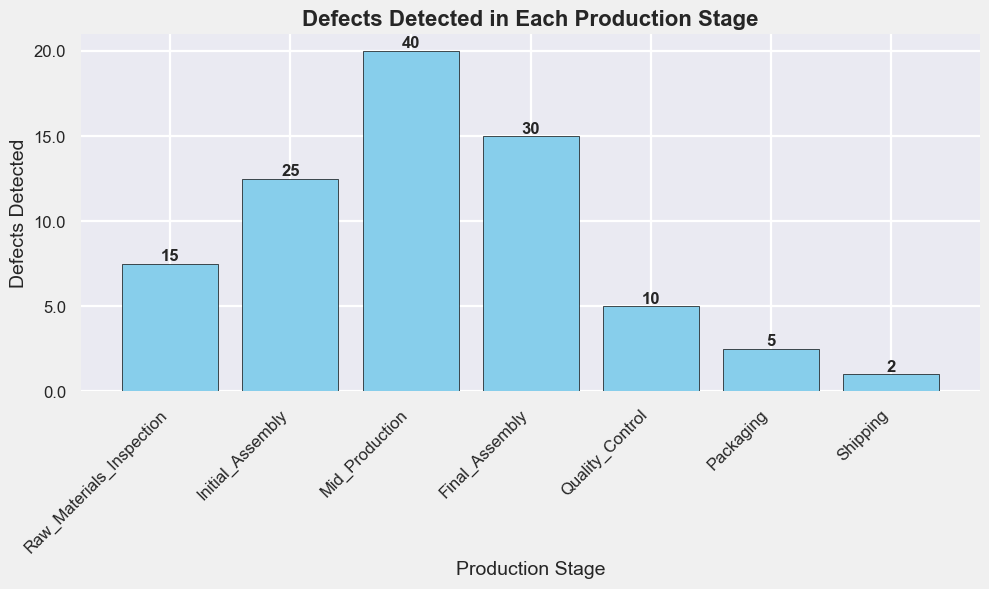Which production stage has the highest number of defects? By looking at the height of each bar, we can see that the 'Mid_Production' stage has the tallest bar. This means it has the highest number of defects.
Answer: Mid_Production Which production stage has the lowest number of defects? By observing the height of each bar and comparing them, we find that the 'Shipping' stage has the shortest bar, indicating the lowest number of defects.
Answer: Shipping How many more defects were detected in the 'Final_Assembly' stage compared to 'Quality_Control'? The number of defects in 'Final_Assembly' is 30 and in 'Quality_Control' is 10. Subtracting these gives us: 30 - 10 = 20.
Answer: 20 What is the total number of defects detected in all production stages? Summing up all the defects detected in each stage: 15 + 25 + 40 + 30 + 10 + 5 + 2 = 127.
Answer: 127 What is the average number of defects detected across all production stages? We sum up the defects detected in all stages, which is 127, and then divide by the number of stages, which is 7: 127 / 7 ≈ 18.14.
Answer: 18.14 How many defects were detected in stages before 'Final_Assembly'? Adding the defects detected from 'Raw_Materials_Inspection' to 'Mid_Production': 15 + 25 + 40 = 80.
Answer: 80 Which production stages have fewer than 10 defects detected? Comparing the heights of the bars, 'Packaging' and 'Shipping' stages have fewer than 10 defects detected, with defects count 5 and 2, respectively.
Answer: Packaging, Shipping Are defects detected in 'Mid_Production' stage more than the sum of 'Packaging' and 'Shipping' stages? The defects in 'Mid_Production' are 40. The sum of defects in 'Packaging' and 'Shipping' is 5 + 2 = 7. Since 40 is greater than 7, the answer is yes.
Answer: Yes What is the difference in defects between the 'Initial_Assembly' and 'Final_Assembly' stages? The number of defects in 'Initial_Assembly' is 25, and in 'Final_Assembly' is 30. Subtracting these gives us: 30 - 25 = 5.
Answer: 5 Which stage(s) detect(s) exactly 10 defects? By looking at the bar heights and corresponding labels, we see that 'Quality_Control' stage has exactly 10 defects detected.
Answer: Quality_Control What's the combined defects count for 'Initial_Assembly' and 'Final_Assembly'? Summing up the defects for 'Initial_Assembly' (25) and 'Final_Assembly' (30): 25 + 30 = 55.
Answer: 55 